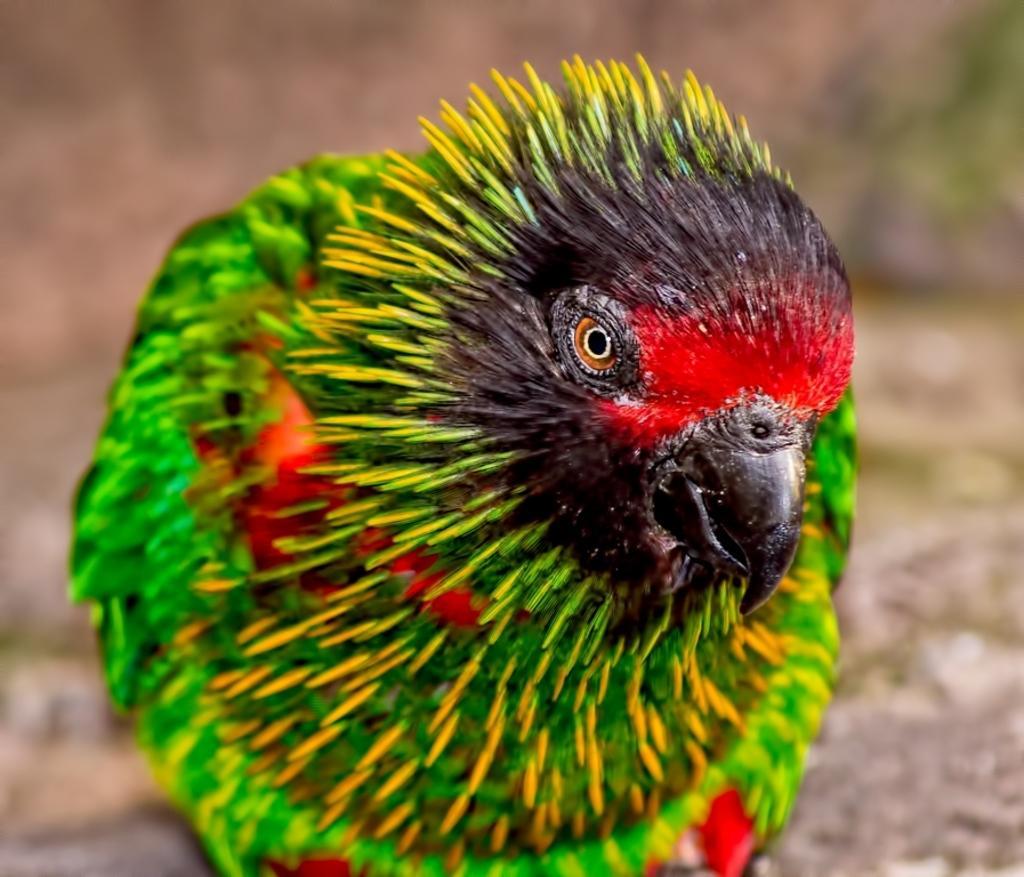Please provide a concise description of this image. In this image I see a bird which is of green, yellow, red and brown in color and I see that it is blurred in the background. 